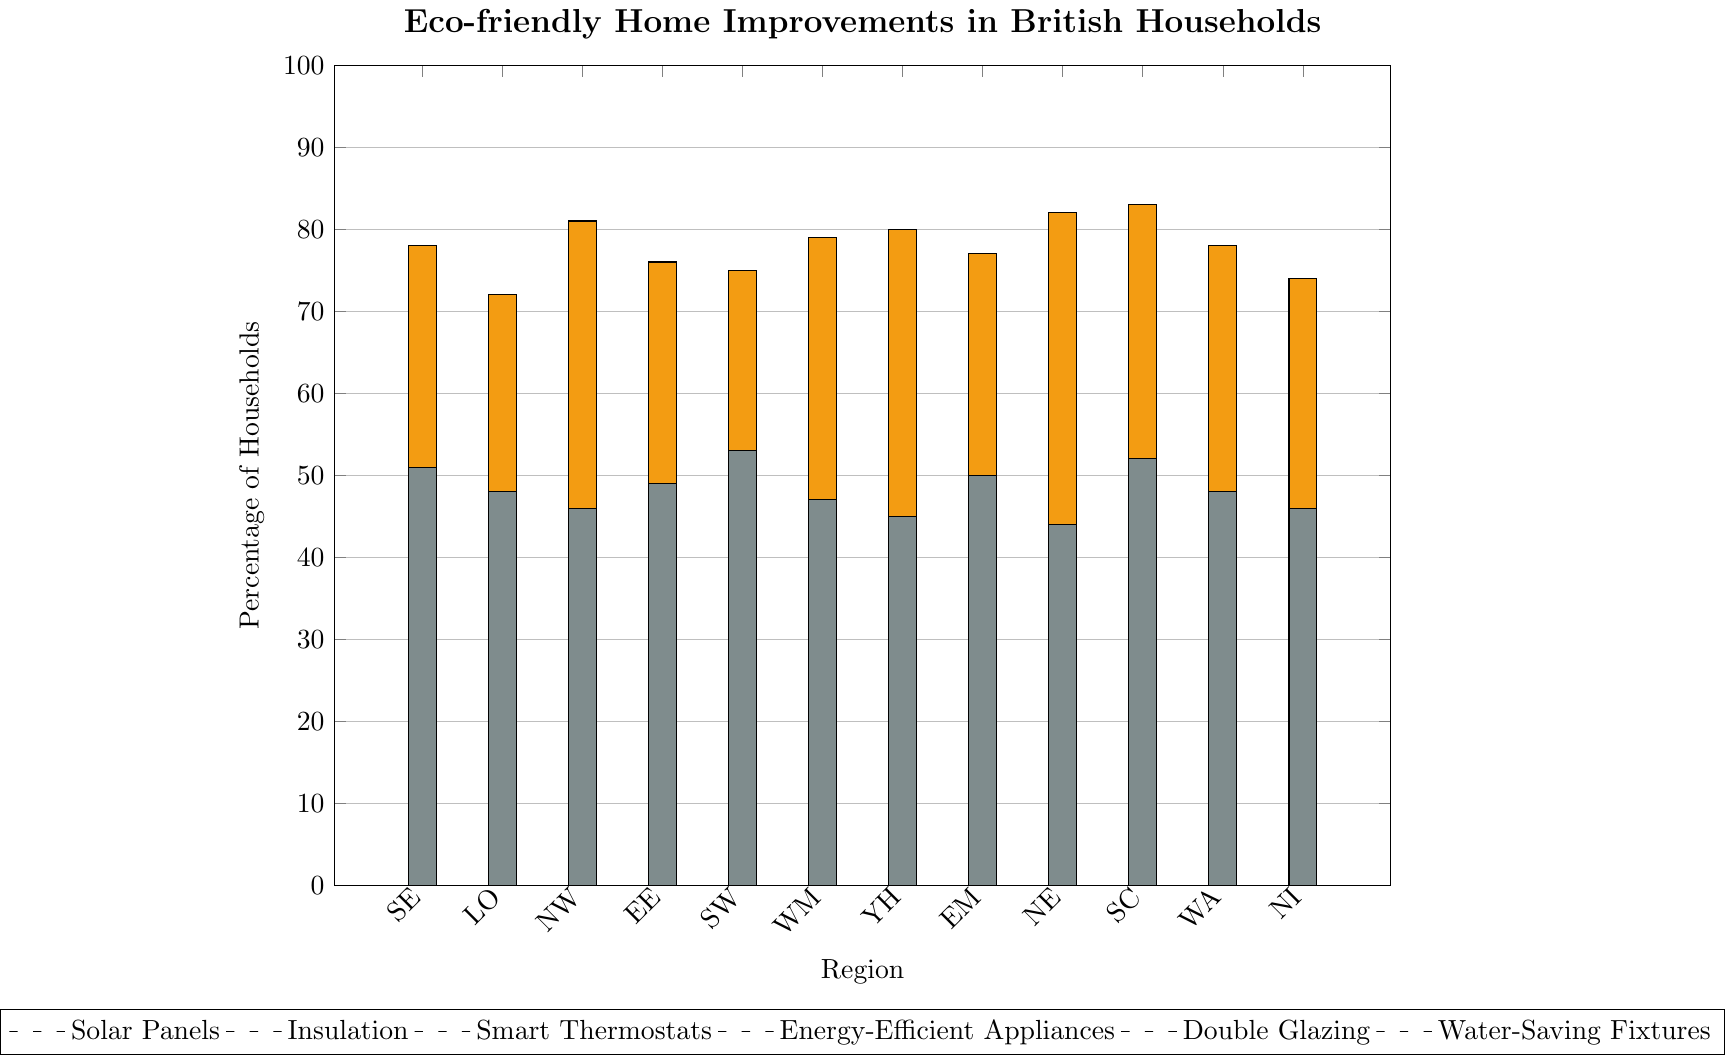Which region has the highest percentage of households with solar panels? Look for the tallest blue bar on the chart representing solar panels.
Answer: South West How does the percentage of households with double glazing in Scotland compare to that in the North East? Identify the heights of the yellow bars for Scotland and the North East, compare their values.
Answer: Scotland has a slightly higher percentage In which region is the adoption of smart thermostats the lowest? Look for the shortest green bar representing smart thermostats.
Answer: Northern Ireland What is the average percentage of households with water-saving fixtures in South East, South West, and Scotland? Add the values from the grey bars for these regions and divide by the number of regions (51 + 53 + 52) / 3 = 156 / 3
Answer: 52 Which eco-friendly improvement is most popular in the North West? Identify the tallest bar within the North West section and note its color.
Answer: Double Glazing How much higher is the adoption of energy-efficient appliances in London compared to Northern Ireland? Subtract the height of the purple bar in Northern Ireland from that in London (65 - 53).
Answer: 12 Compare the percentages of households with insulation in West Midlands and Wales. Which has more? Look at the red bars for both regions and compare.
Answer: West Midlands has more In which region is the difference between the highest and lowest eco-friendly improvement most significant? Calculate the differences for each region by subtracting the smallest value from the largest value, identify the region with the greatest difference.
Answer: Scotland (83 - 31 = 52) How does the adoption of water-saving fixtures in London compare visually to its adoption of solar panels? Evaluate the height and color of the grey bar for water-saving fixtures and the blue bar for solar panels in London.
Answer: Water-saving fixtures bar is higher than solar panels What is the sum of all percentages for double glazing in the East Midlands and East of England? Add the values of the yellow bars for both regions (77 + 76).
Answer: 153 